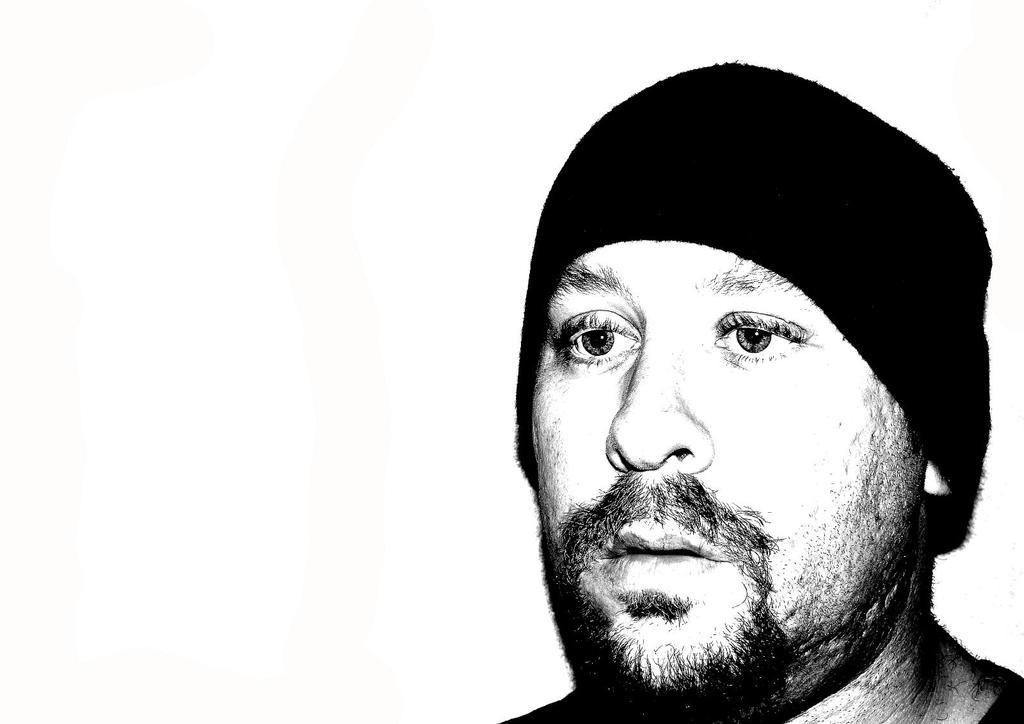What is the color scheme of the image? The image is black and white. Can you describe the person in the image? There is a person in the image. What is the person wearing on their head? The person is wearing a cap. What type of nail is being hammered into the person's hand in the image? There is no nail or hammering action present in the image; it only features a person wearing a cap. 